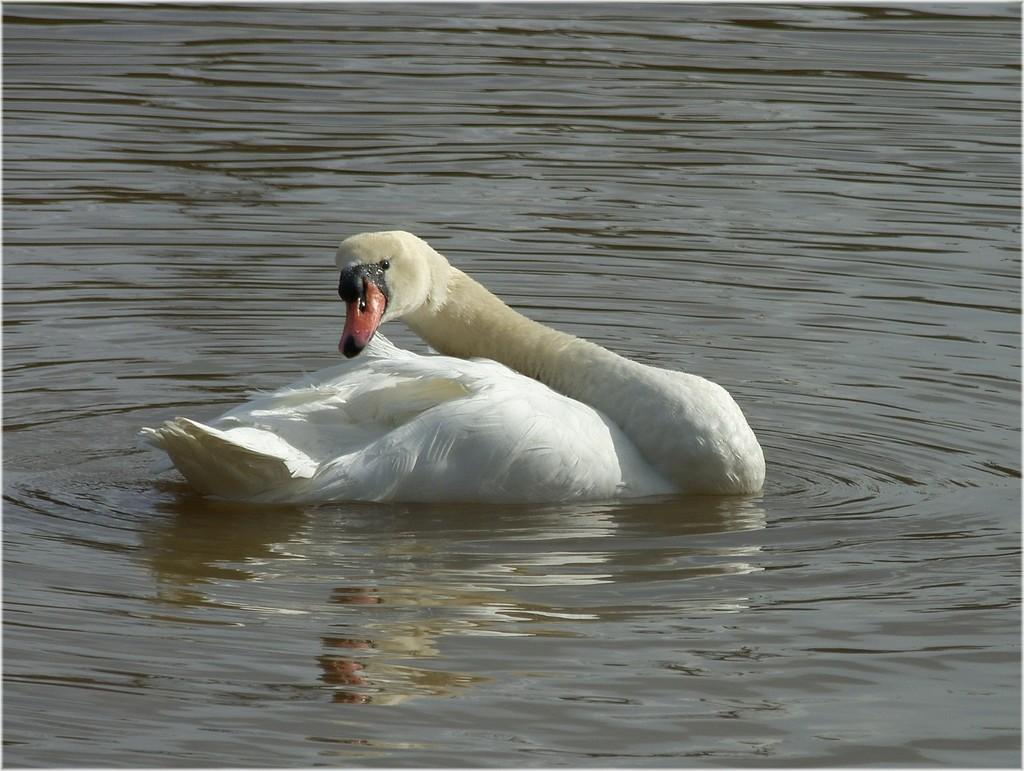What animal is present in the image? There is a duck in the image. What is the duck doing in the image? The duck is floating on the water. What is the environment surrounding the duck? The duck is surrounded by water. What type of cake is the duck holding in the image? There is no cake present in the image; the duck is surrounded by water and not holding any cake. 